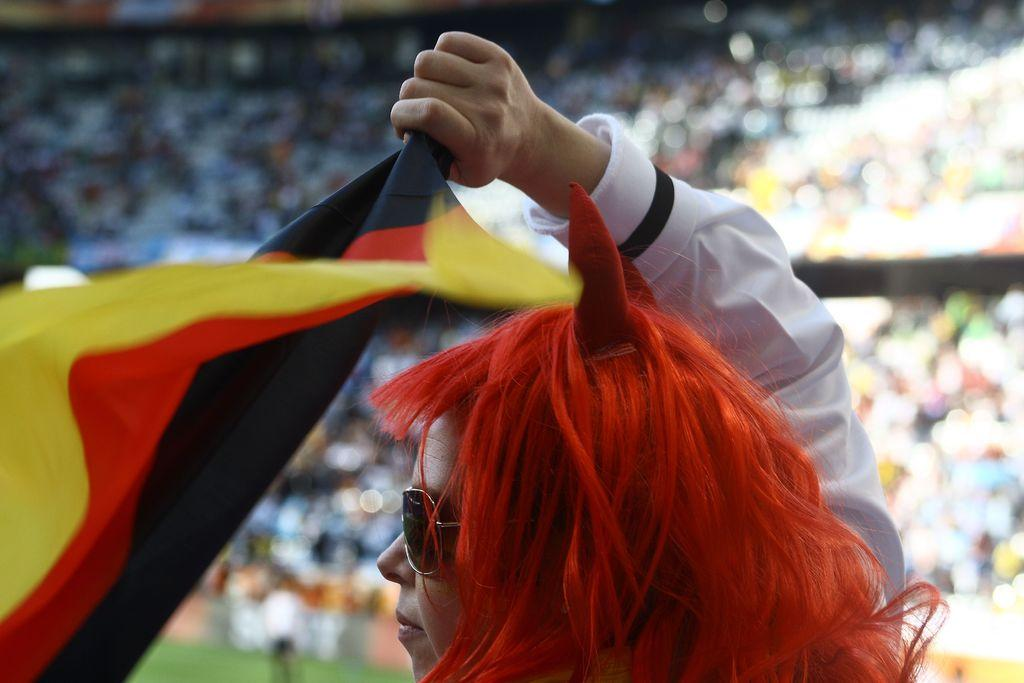Who is the main subject in the image? There is a girl in the image. What is the girl holding in the image? The girl is holding cloth in the image. Can you describe the background of the image? The background is blurred, and there are people visible in the background. How many cows can be seen grazing in the background of the image? There are no cows present in the image; the background is blurred and only includes people. 